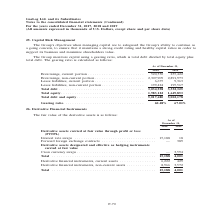From Gaslog's financial document, In which years was the fair value of the derivative assets recorded for? The document shows two values: 2018 and 2019. From the document: ") For the years ended December 31, 2017, 2018 and 2019 (All amounts expressed in thousands of U.S. Dollars, except share and per share data) Continued..." Also, What was the fair value of cross currency swaps in 2019? According to the financial document, 3,594 (in thousands). The relevant text states: "ts carried at fair value Cross currency swaps . — 3,594..." Also, What was the fair value of derivatives non-current assets in 2019? According to the financial document, 3,572 (in thousands). The relevant text states: "financial instruments, non-current assets . 8,966 3,572..." Additionally, In which year was the fair value of  Interest rate swaps  higher? According to the financial document, 2018. The relevant text states: "Continued) For the years ended December 31, 2017, 2018 and 2019 (All amounts expressed in thousands of U.S. Dollars, except share and per share data)..." Also, can you calculate: What was the change in fair value of interest rate swaps from 2018 to 2019? Based on the calculation: 18 - 15,188 , the result is -15170 (in thousands). This is based on the information: "ough profit or loss (FVTPL) Interest rate swaps . 15,188 18 Forward foreign exchange contracts . — 389 Derivative assets designated and effective as hedging ough profit or loss (FVTPL) Interest rate s..." The key data points involved are: 15,188, 18. Also, can you calculate: What was the percentage change in total fair value of the derivative assets from 2018 to 2019? To answer this question, I need to perform calculations using the financial data. The calculation is: (4,001 - 15,188)/15,188 , which equals -73.66 (percentage). This is based on the information: "Total . 15,188 4,001 Total . 15,188 4,001..." The key data points involved are: 15,188, 4,001. 